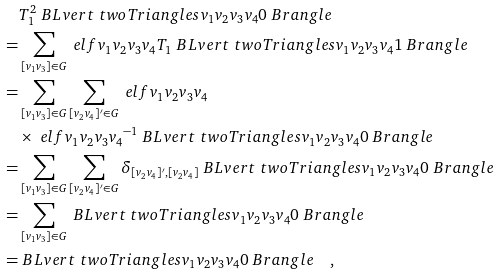Convert formula to latex. <formula><loc_0><loc_0><loc_500><loc_500>& T ^ { 2 } _ { 1 } \ B L v e r t \ t w o T r i a n g l e s { v _ { 1 } } { v _ { 2 } } { v _ { 3 } } { v _ { 4 } } { 0 } \ B r a n g l e \\ = & \sum _ { [ v _ { 1 } v _ { 3 } ] \in G } \ e l f { v _ { 1 } } { v _ { 2 } } { v _ { 3 } } { v _ { 4 } } T _ { 1 } \ B L v e r t \ t w o T r i a n g l e s { v _ { 1 } } { v _ { 2 } } { v _ { 3 } } { v _ { 4 } } { 1 } \ B r a n g l e \\ = & \sum _ { [ v _ { 1 } v _ { 3 } ] \in G } \sum _ { [ v _ { 2 } v _ { 4 } ] ^ { \prime } \in G } \ e l f { v _ { 1 } } { v _ { 2 } } { v _ { 3 } } { v _ { 4 } } \\ & \times \ e l f { v _ { 1 } } { v _ { 2 } } { v _ { 3 } } { v _ { 4 } } ^ { - 1 } \ B L v e r t \ t w o T r i a n g l e s { v _ { 1 } } { v _ { 2 } } { v _ { 3 } } { v _ { 4 } } { 0 } \ B r a n g l e \\ = & \sum _ { [ v _ { 1 } v _ { 3 } ] \in G } \sum _ { [ v _ { 2 } v _ { 4 } ] ^ { \prime } \in G } \delta _ { [ v _ { 2 } v _ { 4 } ] ^ { \prime } , [ v _ { 2 } v _ { 4 } ] } \ B L v e r t \ t w o T r i a n g l e s { v _ { 1 } } { v _ { 2 } } { v _ { 3 } } { v _ { 4 } } { 0 } \ B r a n g l e \\ = & \sum _ { [ v _ { 1 } v _ { 3 } ] \in G } \ B L v e r t \ t w o T r i a n g l e s { v _ { 1 } } { v _ { 2 } } { v _ { 3 } } { v _ { 4 } } { 0 } \ B r a n g l e \\ = & \ B L v e r t \ t w o T r i a n g l e s { v _ { 1 } } { v _ { 2 } } { v _ { 3 } } { v _ { 4 } } { 0 } \ B r a n g l e \quad ,</formula> 